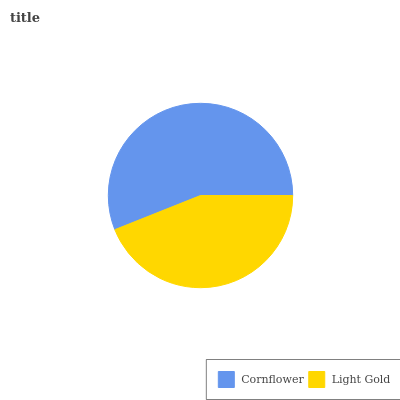Is Light Gold the minimum?
Answer yes or no. Yes. Is Cornflower the maximum?
Answer yes or no. Yes. Is Light Gold the maximum?
Answer yes or no. No. Is Cornflower greater than Light Gold?
Answer yes or no. Yes. Is Light Gold less than Cornflower?
Answer yes or no. Yes. Is Light Gold greater than Cornflower?
Answer yes or no. No. Is Cornflower less than Light Gold?
Answer yes or no. No. Is Cornflower the high median?
Answer yes or no. Yes. Is Light Gold the low median?
Answer yes or no. Yes. Is Light Gold the high median?
Answer yes or no. No. Is Cornflower the low median?
Answer yes or no. No. 